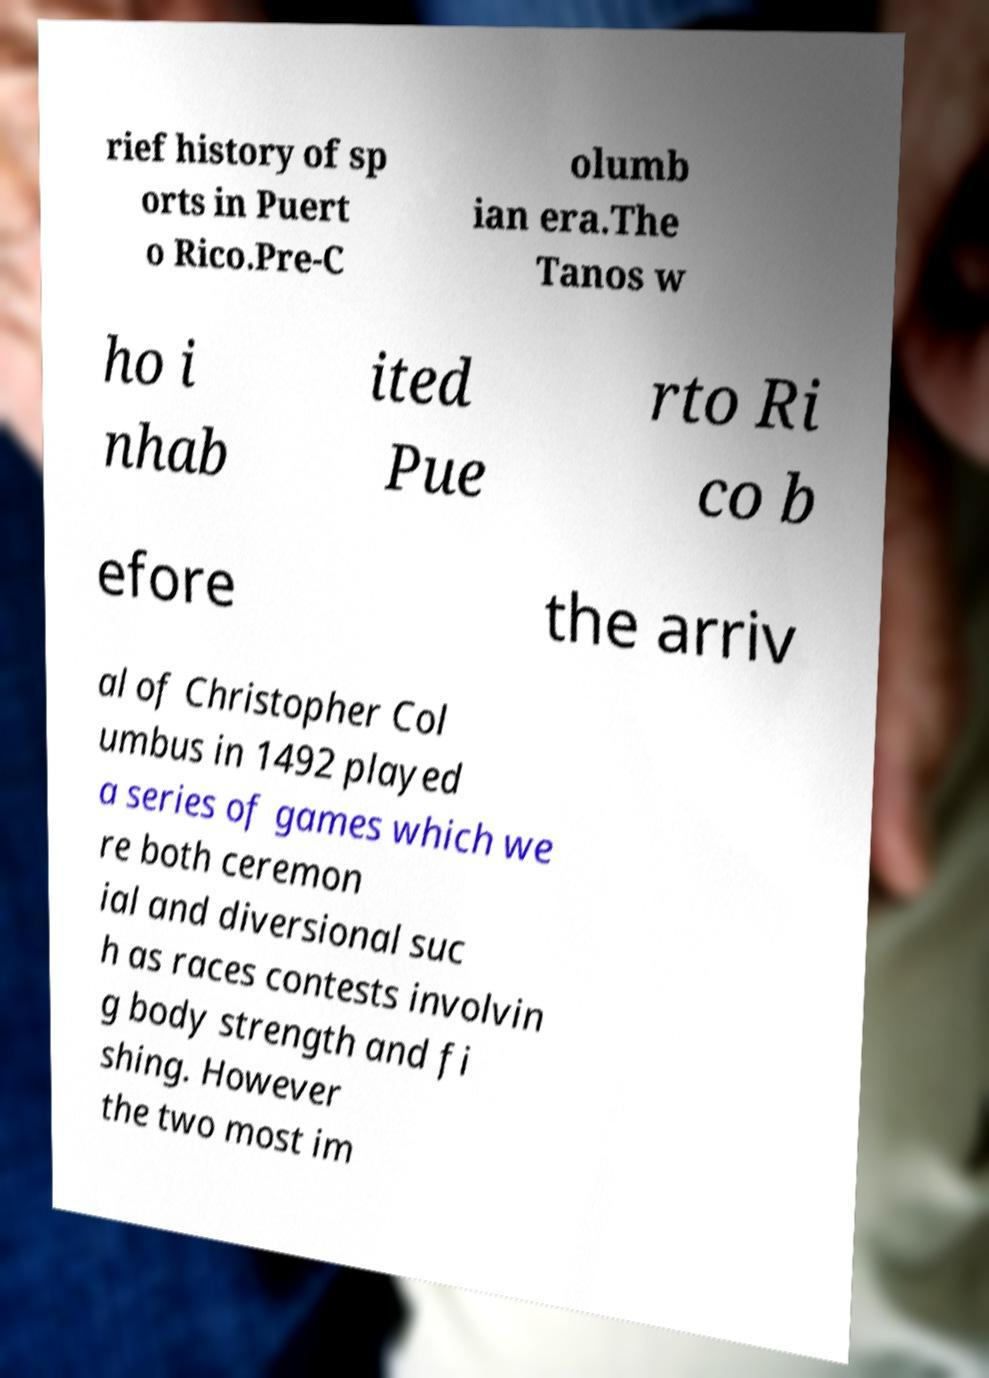There's text embedded in this image that I need extracted. Can you transcribe it verbatim? rief history of sp orts in Puert o Rico.Pre-C olumb ian era.The Tanos w ho i nhab ited Pue rto Ri co b efore the arriv al of Christopher Col umbus in 1492 played a series of games which we re both ceremon ial and diversional suc h as races contests involvin g body strength and fi shing. However the two most im 